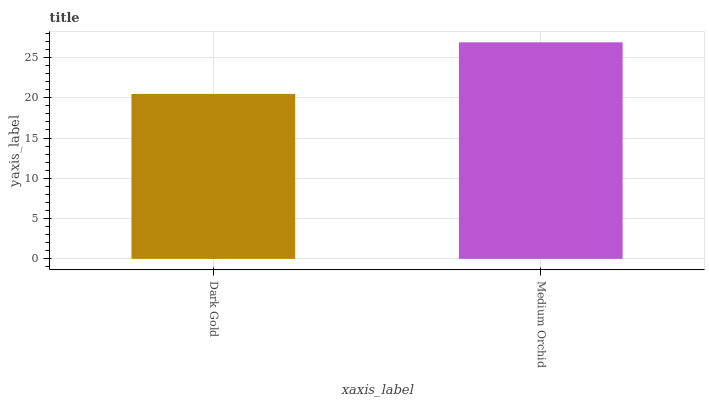Is Medium Orchid the minimum?
Answer yes or no. No. Is Medium Orchid greater than Dark Gold?
Answer yes or no. Yes. Is Dark Gold less than Medium Orchid?
Answer yes or no. Yes. Is Dark Gold greater than Medium Orchid?
Answer yes or no. No. Is Medium Orchid less than Dark Gold?
Answer yes or no. No. Is Medium Orchid the high median?
Answer yes or no. Yes. Is Dark Gold the low median?
Answer yes or no. Yes. Is Dark Gold the high median?
Answer yes or no. No. Is Medium Orchid the low median?
Answer yes or no. No. 